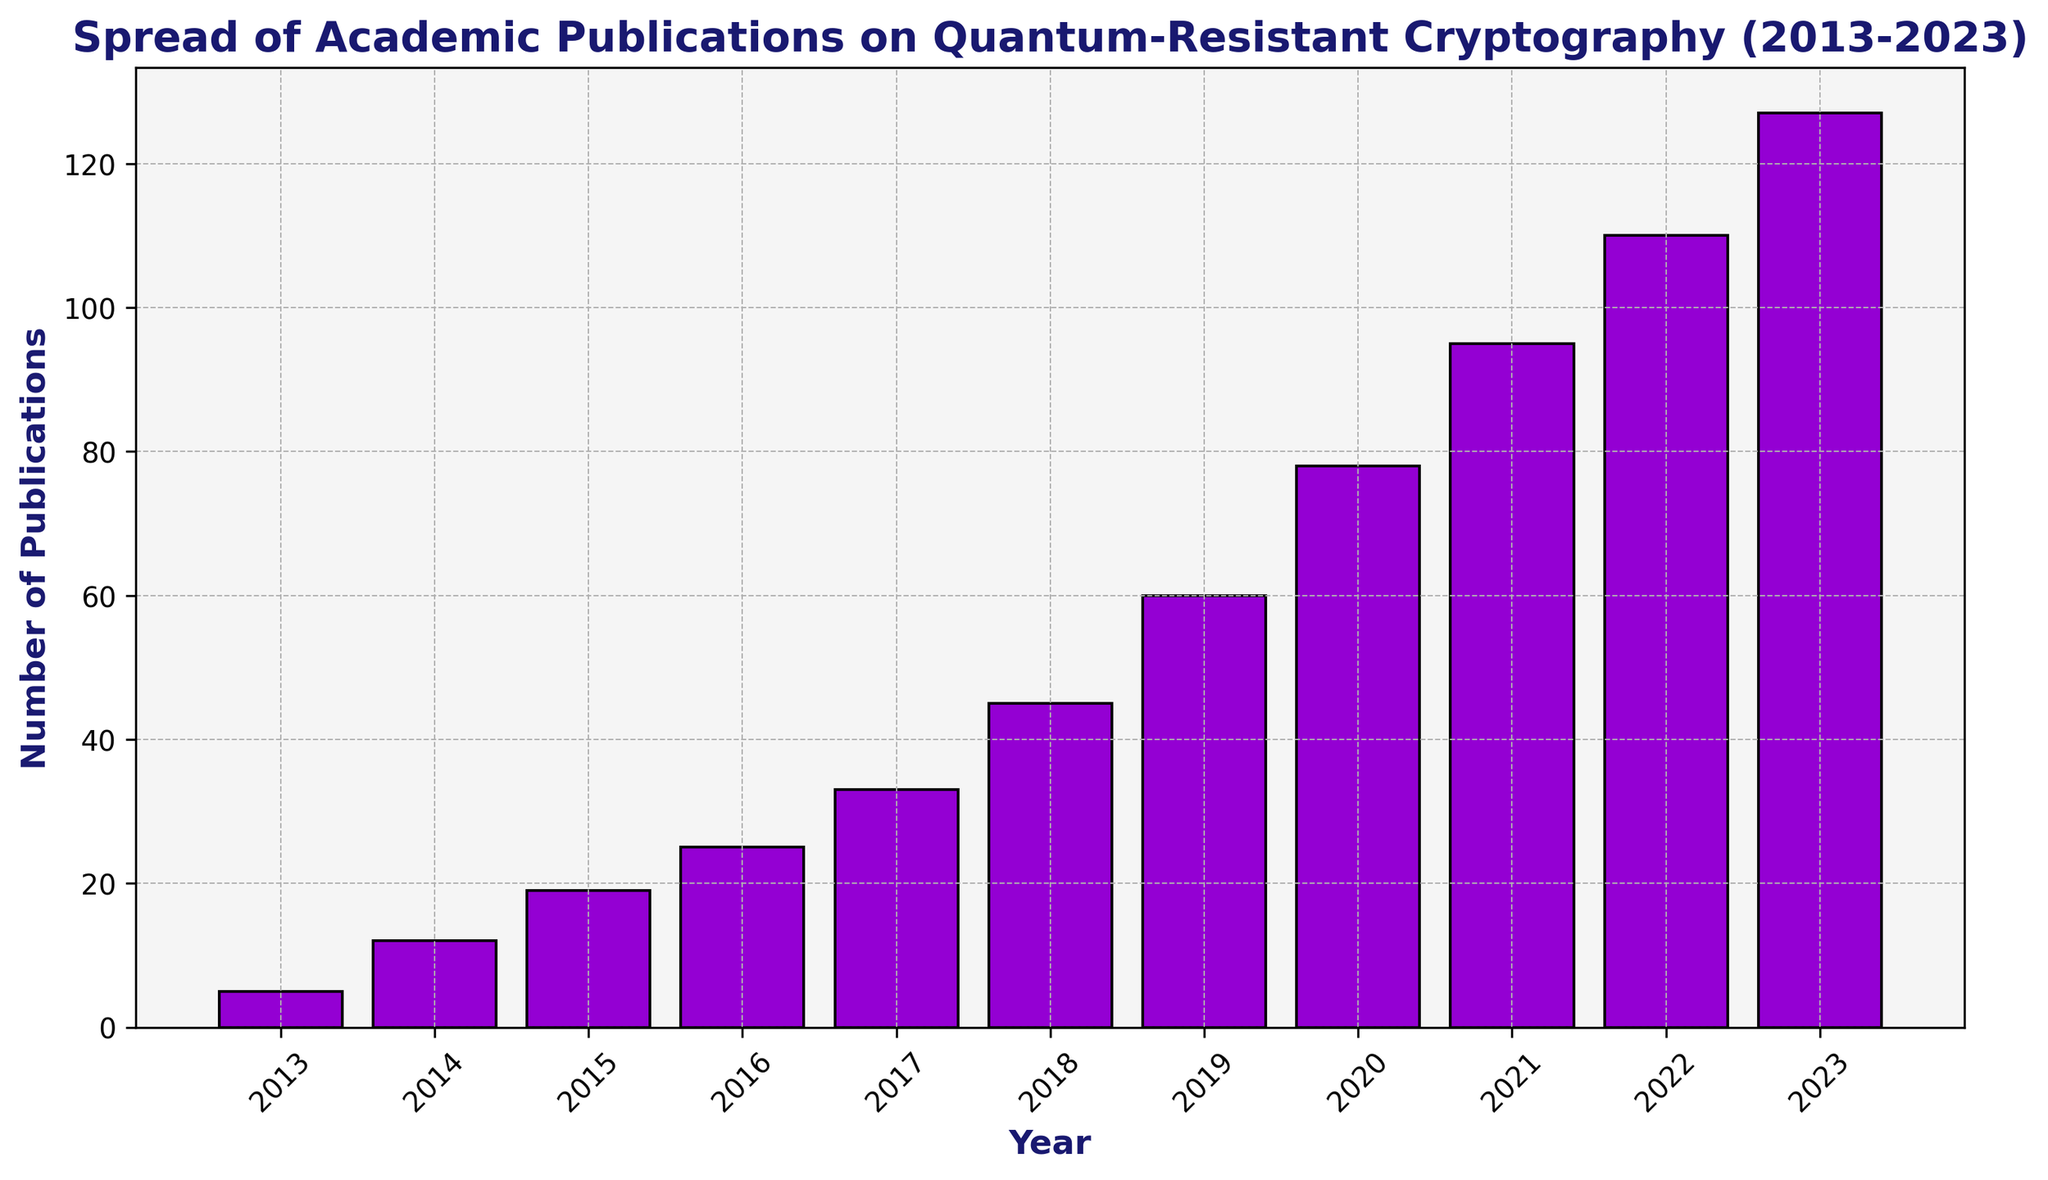What's the total number of publications between 2013 and 2023? To find the total number, sum up the number of publications for each year: 5 + 12 + 19 + 25 + 33 + 45 + 60 + 78 + 95 + 110 + 127 = 609
Answer: 609 Which year saw the highest number of publications? Look at the height of the bars and find the one that is the tallest, which corresponds to the year 2023 with 127 publications
Answer: 2023 How many more publications were there in 2023 compared to 2013? Subtract the number of publications in 2013 from 2023: 127 - 5 = 122
Answer: 122 What is the average number of publications per year over the decade? Calculate the average by dividing the total number of publications (609) by the number of years (11): 609 / 11 ≈ 55.36
Answer: 55.36 Did the number of publications increase every year? Compare the number of publications year by year, and see that each year's bar is higher than the previous year's bar
Answer: Yes How many more publications were there in 2020 compared to 2015? Subtract the number of publications in 2015 from 2020: 78 - 19 = 59
Answer: 59 Which two consecutive years had the greatest increase in the number of publications? Calculate the difference for each consecutive year pair: 2014-2013 = 7, 2015-2014 = 7, 2016-2015 = 6, 2017-2016 = 8, 2018-2017 = 12, 2019-2018 = 15, 2020-2019 = 18, 2021-2020 = 17, 2022-2021 = 15, 2023-2022 = 17. The greatest increase was between 2019 and 2020, with an increase of 18
Answer: 2019-2020 What is the difference in the number of publications between the first and the last three years? Sum the number of publications from 2013-2015 and from 2021-2023: (5 + 12 + 19) = 36 and (95 + 110 + 127) = 332, then find the difference: 332 - 36 = 296
Answer: 296 What pattern do you observe in the growth of publications over the last decade? The bars show a consistent growth trend each year with an accelerating increase, particularly in the later years
Answer: Consistent and accelerating growth 